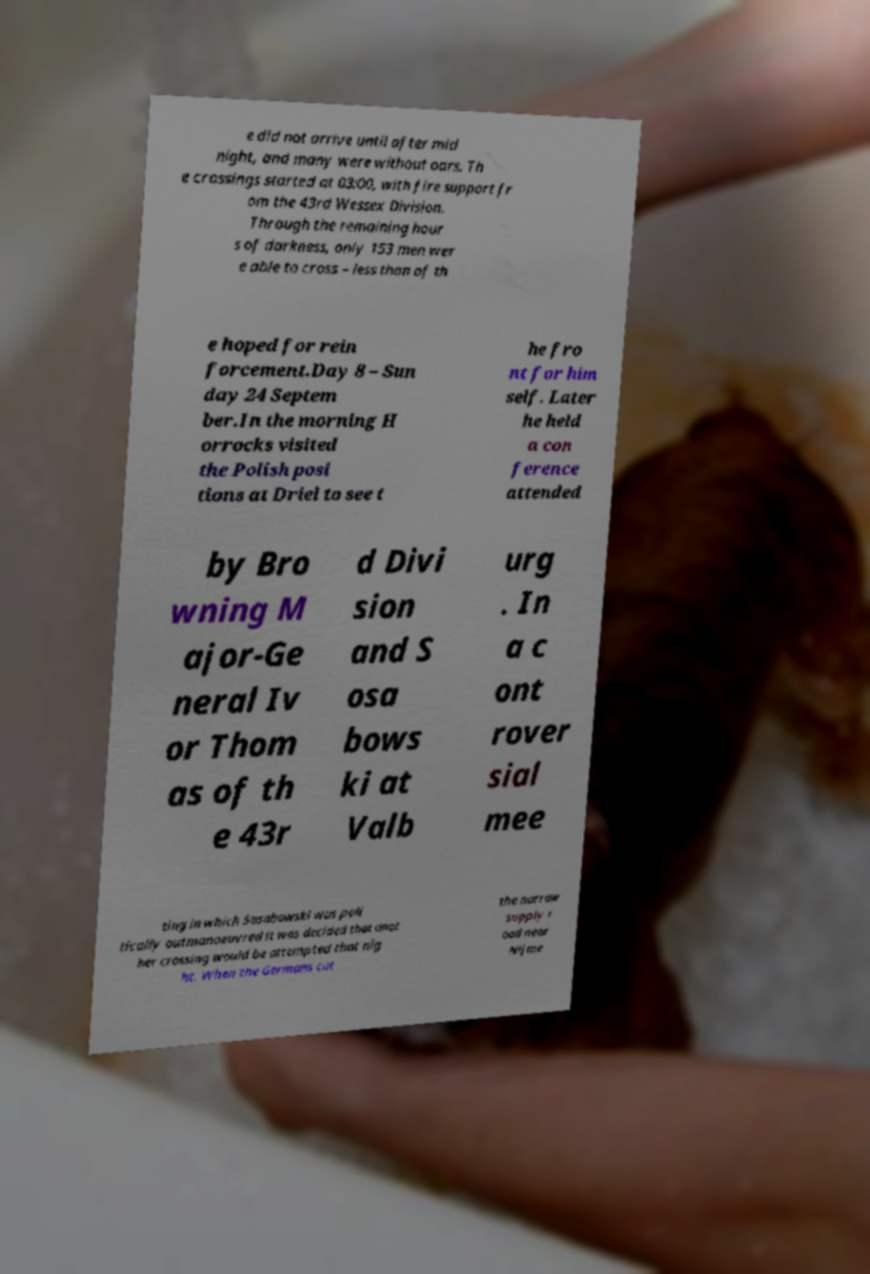There's text embedded in this image that I need extracted. Can you transcribe it verbatim? e did not arrive until after mid night, and many were without oars. Th e crossings started at 03:00, with fire support fr om the 43rd Wessex Division. Through the remaining hour s of darkness, only 153 men wer e able to cross – less than of th e hoped for rein forcement.Day 8 – Sun day 24 Septem ber.In the morning H orrocks visited the Polish posi tions at Driel to see t he fro nt for him self. Later he held a con ference attended by Bro wning M ajor-Ge neral Iv or Thom as of th e 43r d Divi sion and S osa bows ki at Valb urg . In a c ont rover sial mee ting in which Sosabowski was poli tically outmanoeuvred it was decided that anot her crossing would be attempted that nig ht. When the Germans cut the narrow supply r oad near Nijme 